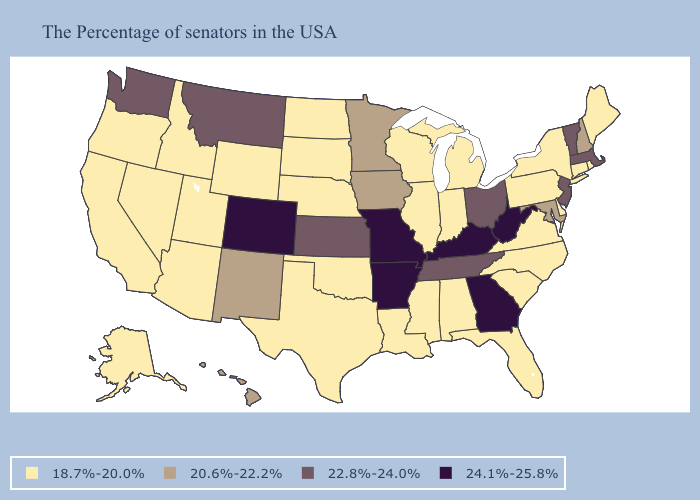What is the highest value in states that border Oregon?
Keep it brief. 22.8%-24.0%. What is the highest value in states that border Utah?
Write a very short answer. 24.1%-25.8%. Does Florida have the same value as Arkansas?
Answer briefly. No. Is the legend a continuous bar?
Write a very short answer. No. Name the states that have a value in the range 20.6%-22.2%?
Answer briefly. New Hampshire, Maryland, Minnesota, Iowa, New Mexico, Hawaii. What is the value of New Jersey?
Short answer required. 22.8%-24.0%. What is the lowest value in the MidWest?
Keep it brief. 18.7%-20.0%. What is the value of Massachusetts?
Give a very brief answer. 22.8%-24.0%. What is the lowest value in the USA?
Short answer required. 18.7%-20.0%. Among the states that border Wisconsin , which have the highest value?
Keep it brief. Minnesota, Iowa. Does Michigan have the lowest value in the MidWest?
Be succinct. Yes. Name the states that have a value in the range 22.8%-24.0%?
Short answer required. Massachusetts, Vermont, New Jersey, Ohio, Tennessee, Kansas, Montana, Washington. What is the lowest value in the USA?
Write a very short answer. 18.7%-20.0%. Does Kentucky have the highest value in the South?
Concise answer only. Yes. Does South Dakota have the highest value in the MidWest?
Answer briefly. No. 